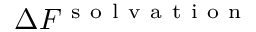<formula> <loc_0><loc_0><loc_500><loc_500>\Delta F ^ { s o l v a t i o n }</formula> 